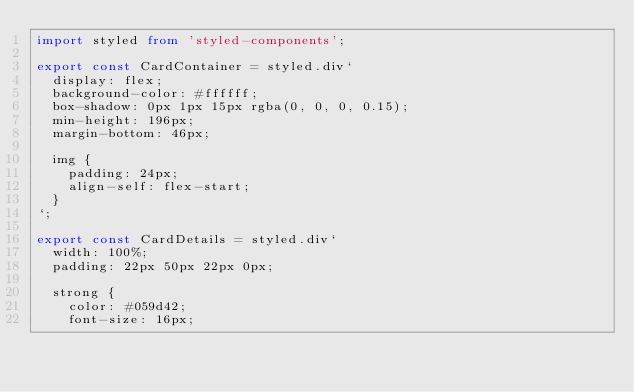Convert code to text. <code><loc_0><loc_0><loc_500><loc_500><_TypeScript_>import styled from 'styled-components';

export const CardContainer = styled.div`
  display: flex;
  background-color: #ffffff;
  box-shadow: 0px 1px 15px rgba(0, 0, 0, 0.15);
  min-height: 196px;
  margin-bottom: 46px;

  img {
    padding: 24px;
    align-self: flex-start;
  }
`;

export const CardDetails = styled.div`
  width: 100%;
  padding: 22px 50px 22px 0px;

  strong {
    color: #059d42;
    font-size: 16px;</code> 